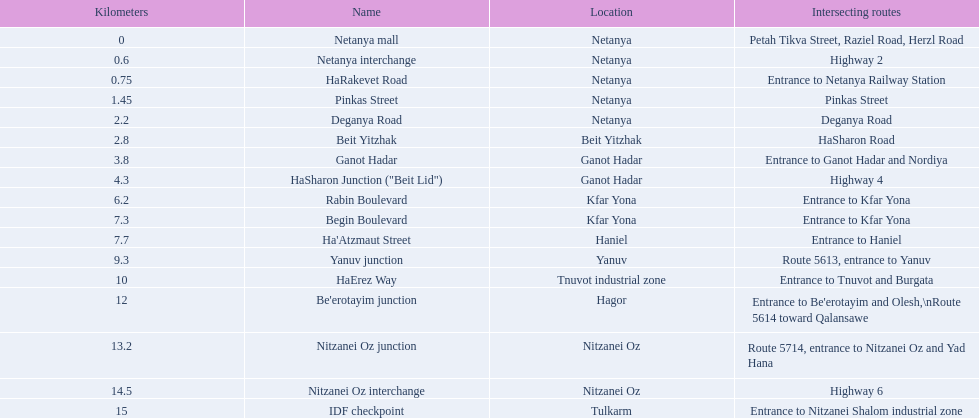What are all the names? Netanya mall, Netanya interchange, HaRakevet Road, Pinkas Street, Deganya Road, Beit Yitzhak, Ganot Hadar, HaSharon Junction ("Beit Lid"), Rabin Boulevard, Begin Boulevard, Ha'Atzmaut Street, Yanuv junction, HaErez Way, Be'erotayim junction, Nitzanei Oz junction, Nitzanei Oz interchange, IDF checkpoint. Where do they intersect? Petah Tikva Street, Raziel Road, Herzl Road, Highway 2, Entrance to Netanya Railway Station, Pinkas Street, Deganya Road, HaSharon Road, Entrance to Ganot Hadar and Nordiya, Highway 4, Entrance to Kfar Yona, Entrance to Kfar Yona, Entrance to Haniel, Route 5613, entrance to Yanuv, Entrance to Tnuvot and Burgata, Entrance to Be'erotayim and Olesh,\nRoute 5614 toward Qalansawe, Route 5714, entrance to Nitzanei Oz and Yad Hana, Highway 6, Entrance to Nitzanei Shalom industrial zone. And which shares an intersection with rabin boulevard? Begin Boulevard. 